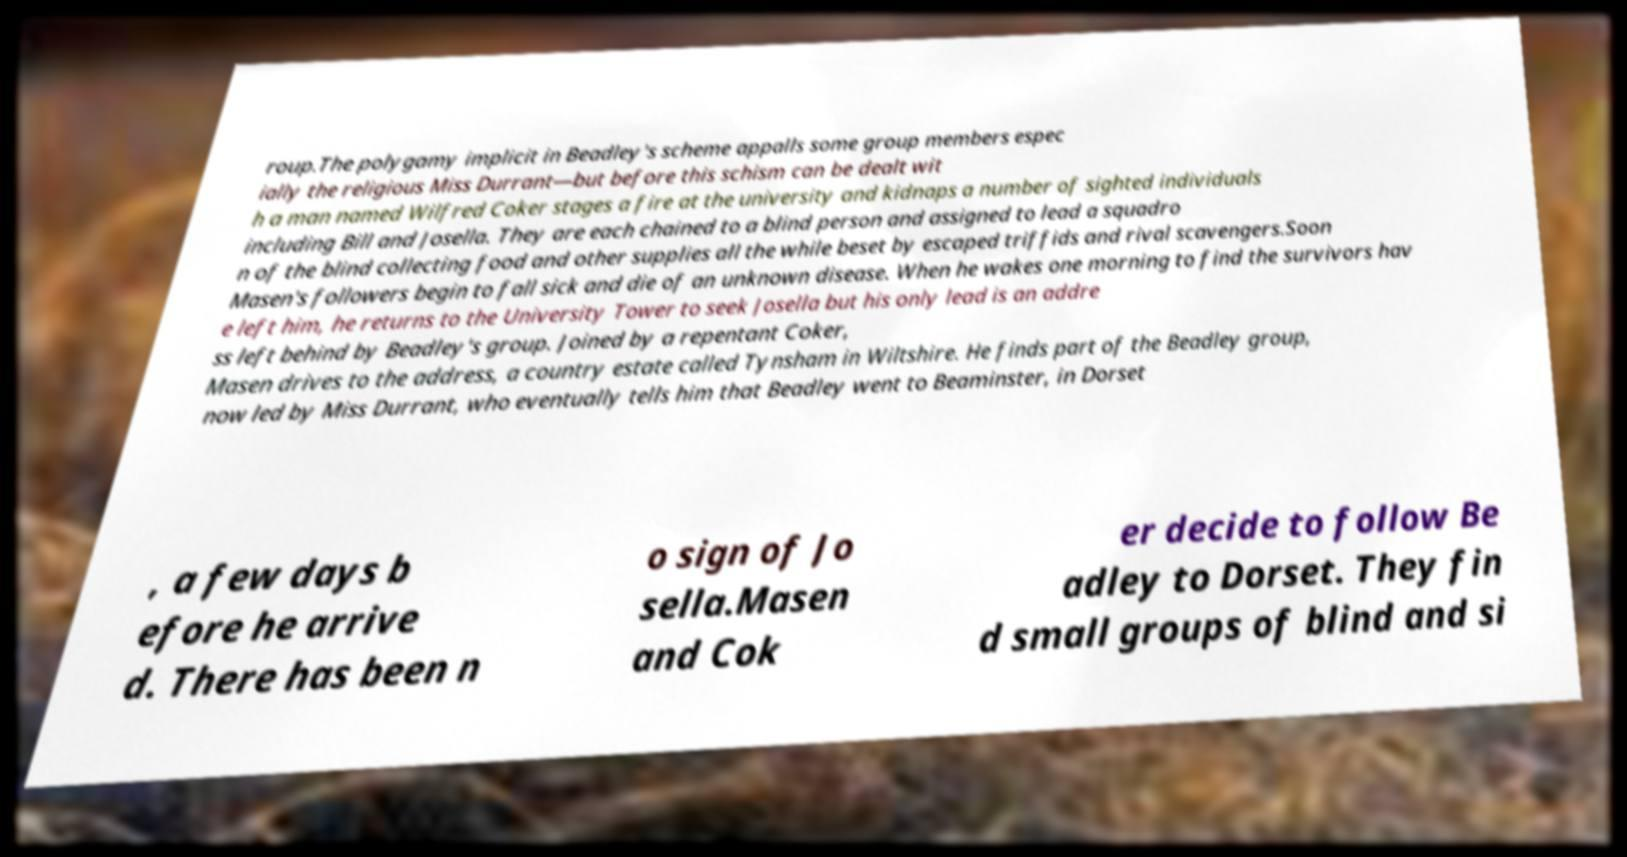Please identify and transcribe the text found in this image. roup.The polygamy implicit in Beadley's scheme appalls some group members espec ially the religious Miss Durrant—but before this schism can be dealt wit h a man named Wilfred Coker stages a fire at the university and kidnaps a number of sighted individuals including Bill and Josella. They are each chained to a blind person and assigned to lead a squadro n of the blind collecting food and other supplies all the while beset by escaped triffids and rival scavengers.Soon Masen's followers begin to fall sick and die of an unknown disease. When he wakes one morning to find the survivors hav e left him, he returns to the University Tower to seek Josella but his only lead is an addre ss left behind by Beadley's group. Joined by a repentant Coker, Masen drives to the address, a country estate called Tynsham in Wiltshire. He finds part of the Beadley group, now led by Miss Durrant, who eventually tells him that Beadley went to Beaminster, in Dorset , a few days b efore he arrive d. There has been n o sign of Jo sella.Masen and Cok er decide to follow Be adley to Dorset. They fin d small groups of blind and si 